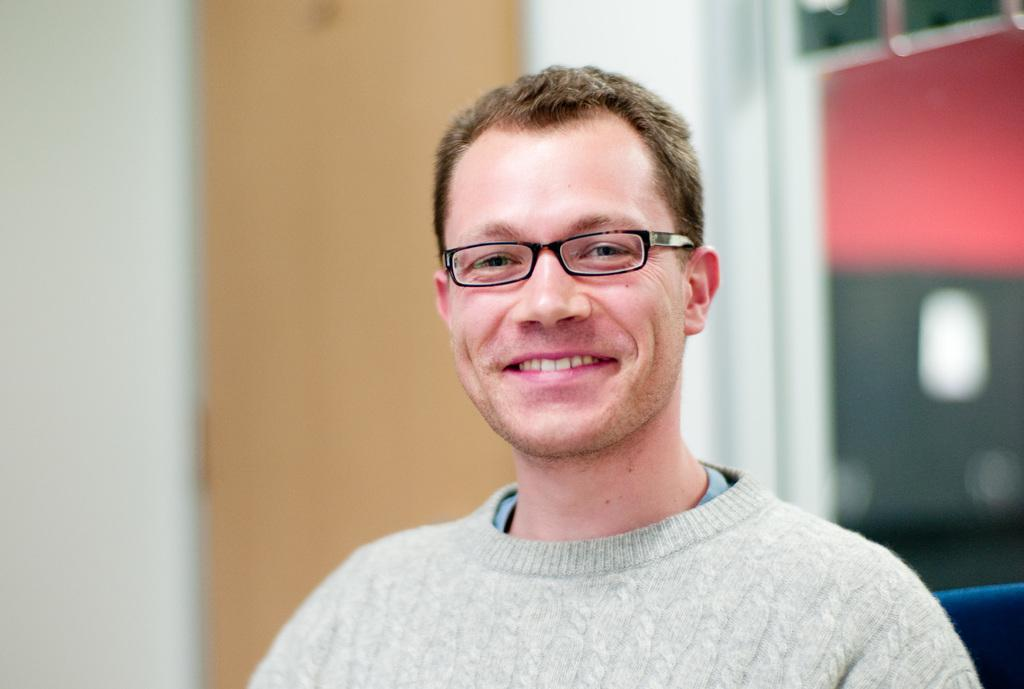What is the person in the image doing? The person is sitting inside a room. What is the person sitting on? The person is sitting on a chair. What can be seen on the glass door in the image? There are reflections on the glass door. What type of object made of wood can be seen in the image? There is a wooden object in the image. What type of heart condition does the person in the image have? There is no information about the person's health or any heart condition in the image. Is there a woman in the image? The provided facts do not mention the gender of the person sitting in the room, so we cannot definitively say if it is a woman or not. 